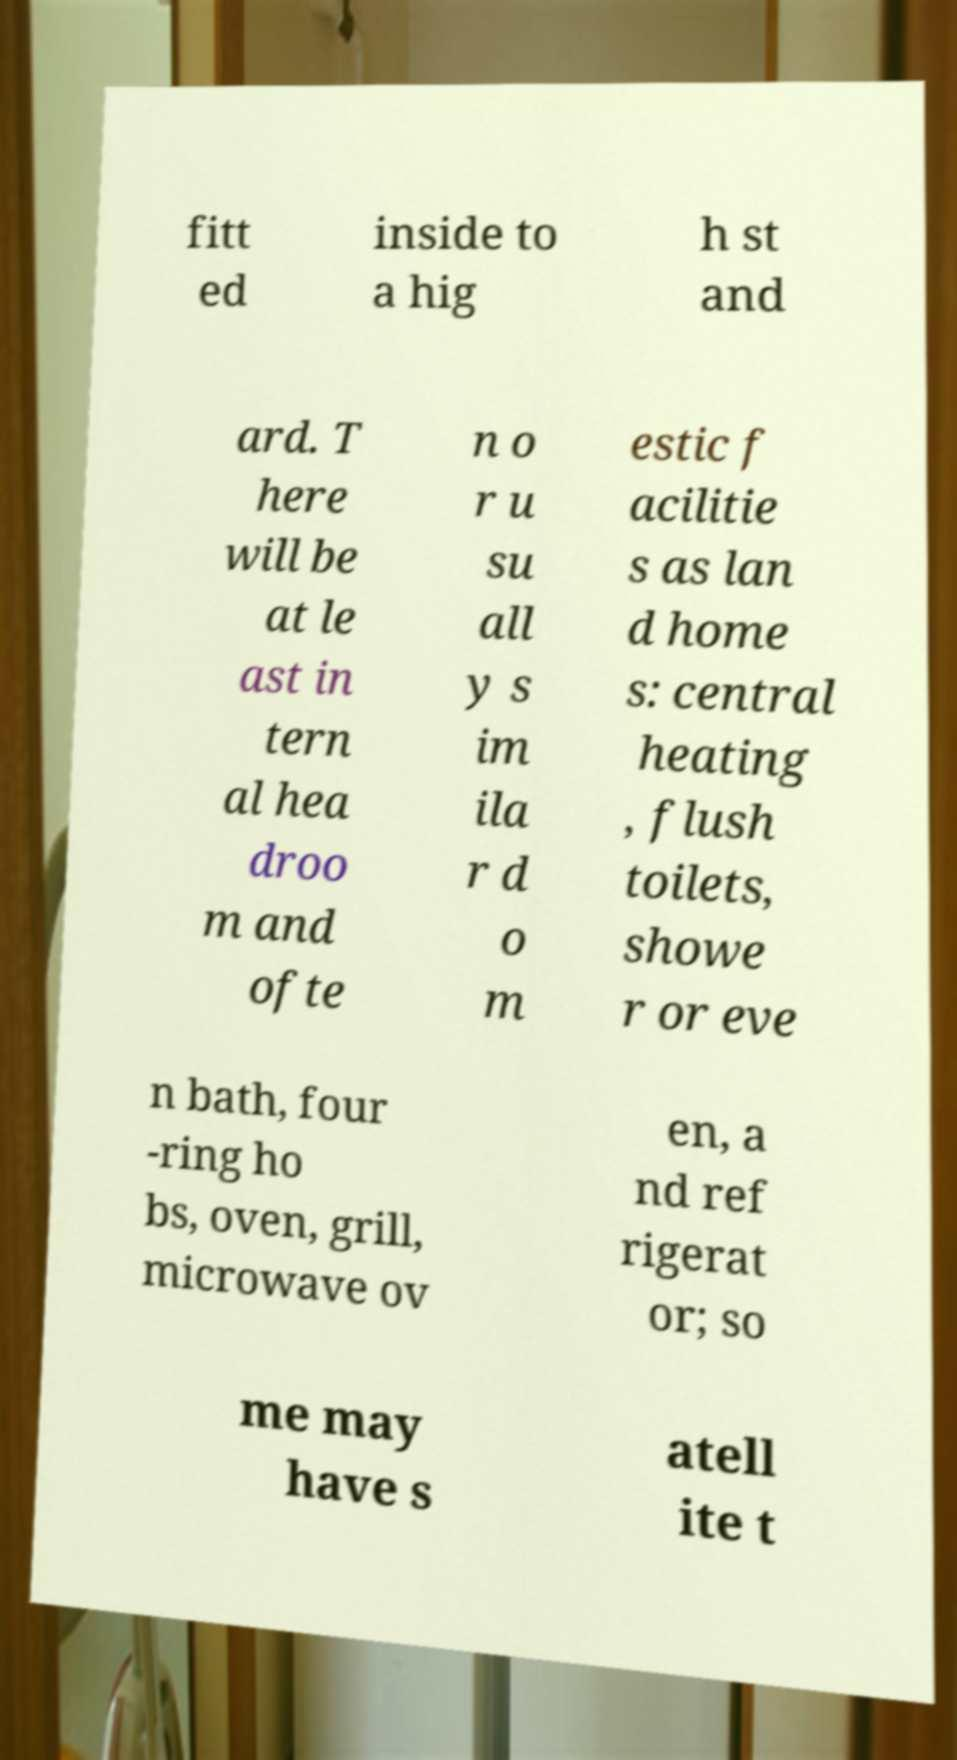Can you accurately transcribe the text from the provided image for me? fitt ed inside to a hig h st and ard. T here will be at le ast in tern al hea droo m and ofte n o r u su all y s im ila r d o m estic f acilitie s as lan d home s: central heating , flush toilets, showe r or eve n bath, four -ring ho bs, oven, grill, microwave ov en, a nd ref rigerat or; so me may have s atell ite t 